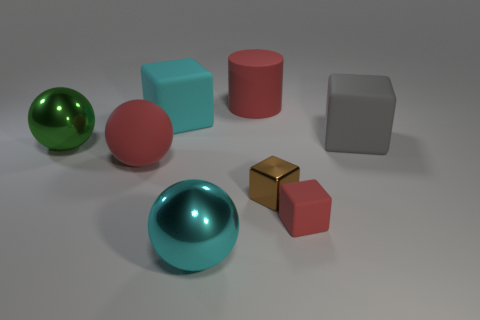Add 1 tiny objects. How many objects exist? 9 Subtract all blue blocks. Subtract all green cylinders. How many blocks are left? 4 Subtract all cylinders. How many objects are left? 7 Add 7 big red matte balls. How many big red matte balls exist? 8 Subtract 0 green blocks. How many objects are left? 8 Subtract all tiny brown shiny things. Subtract all large cyan spheres. How many objects are left? 6 Add 1 large green metal balls. How many large green metal balls are left? 2 